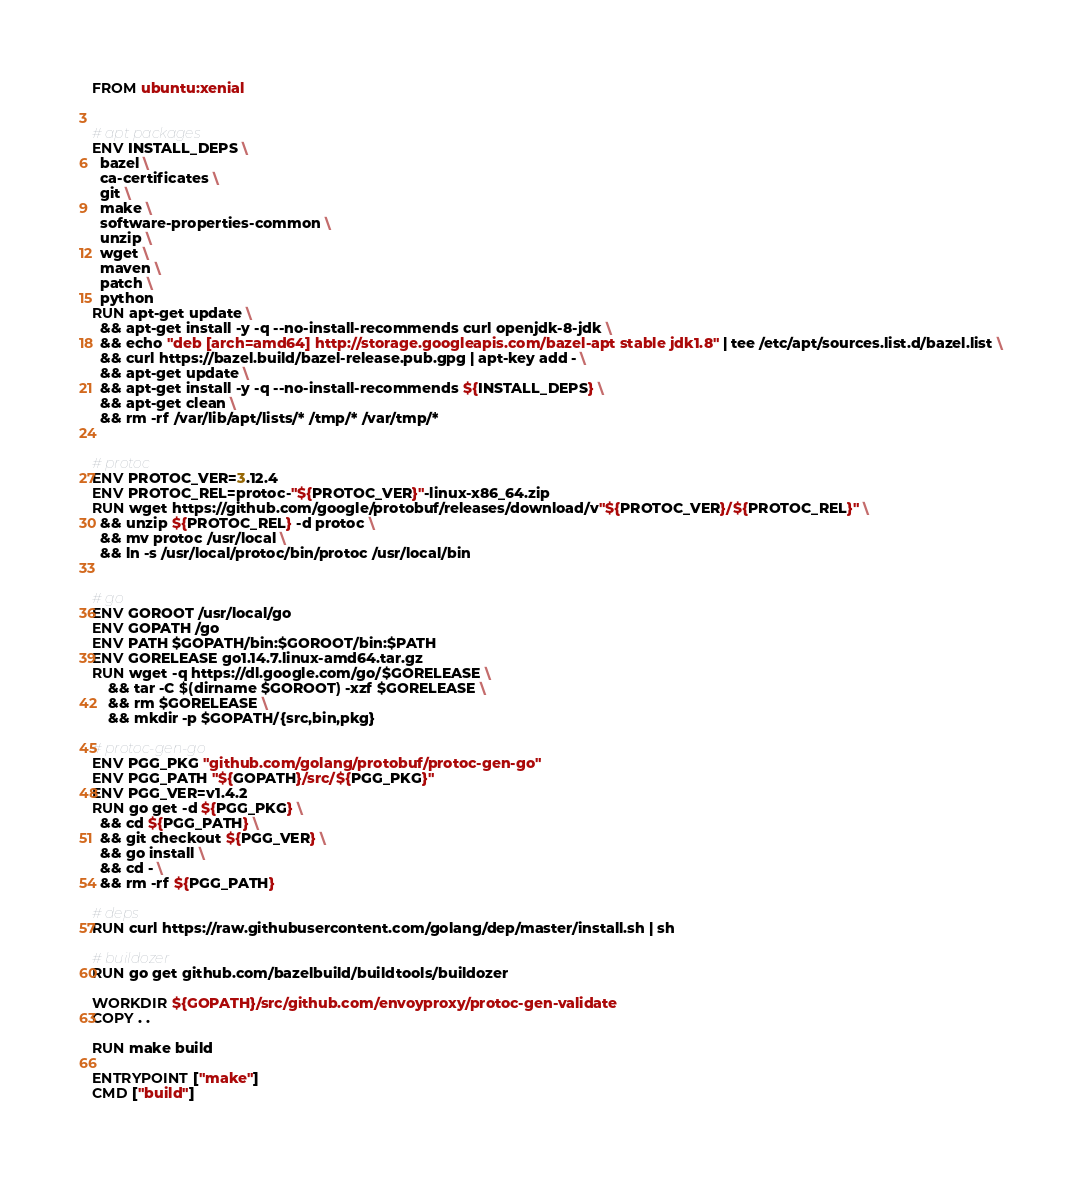Convert code to text. <code><loc_0><loc_0><loc_500><loc_500><_Dockerfile_>FROM ubuntu:xenial


# apt packages
ENV INSTALL_DEPS \
  bazel \
  ca-certificates \
  git \
  make \
  software-properties-common \
  unzip \
  wget \
  maven \
  patch \
  python
RUN apt-get update \
  && apt-get install -y -q --no-install-recommends curl openjdk-8-jdk \
  && echo "deb [arch=amd64] http://storage.googleapis.com/bazel-apt stable jdk1.8" | tee /etc/apt/sources.list.d/bazel.list \
  && curl https://bazel.build/bazel-release.pub.gpg | apt-key add - \
  && apt-get update \
  && apt-get install -y -q --no-install-recommends ${INSTALL_DEPS} \
  && apt-get clean \
  && rm -rf /var/lib/apt/lists/* /tmp/* /var/tmp/*


# protoc
ENV PROTOC_VER=3.12.4
ENV PROTOC_REL=protoc-"${PROTOC_VER}"-linux-x86_64.zip
RUN wget https://github.com/google/protobuf/releases/download/v"${PROTOC_VER}/${PROTOC_REL}" \
  && unzip ${PROTOC_REL} -d protoc \
  && mv protoc /usr/local \
  && ln -s /usr/local/protoc/bin/protoc /usr/local/bin


# go
ENV GOROOT /usr/local/go
ENV GOPATH /go
ENV PATH $GOPATH/bin:$GOROOT/bin:$PATH
ENV GORELEASE go1.14.7.linux-amd64.tar.gz
RUN wget -q https://dl.google.com/go/$GORELEASE \
    && tar -C $(dirname $GOROOT) -xzf $GORELEASE \
    && rm $GORELEASE \
    && mkdir -p $GOPATH/{src,bin,pkg}

# protoc-gen-go
ENV PGG_PKG "github.com/golang/protobuf/protoc-gen-go"
ENV PGG_PATH "${GOPATH}/src/${PGG_PKG}"
ENV PGG_VER=v1.4.2
RUN go get -d ${PGG_PKG} \
  && cd ${PGG_PATH} \
  && git checkout ${PGG_VER} \
  && go install \
  && cd - \
  && rm -rf ${PGG_PATH}

# deps
RUN curl https://raw.githubusercontent.com/golang/dep/master/install.sh | sh

# buildozer
RUN go get github.com/bazelbuild/buildtools/buildozer

WORKDIR ${GOPATH}/src/github.com/envoyproxy/protoc-gen-validate
COPY . .

RUN make build

ENTRYPOINT ["make"]
CMD ["build"]
</code> 